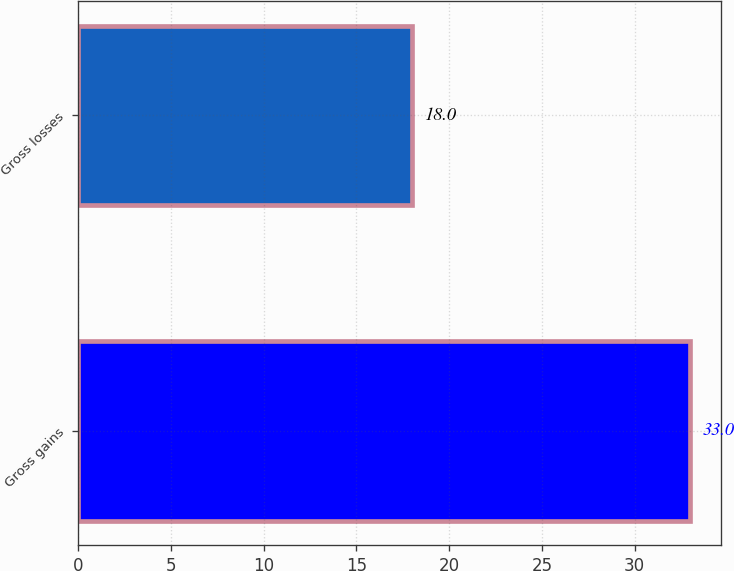Convert chart. <chart><loc_0><loc_0><loc_500><loc_500><bar_chart><fcel>Gross gains<fcel>Gross losses<nl><fcel>33<fcel>18<nl></chart> 